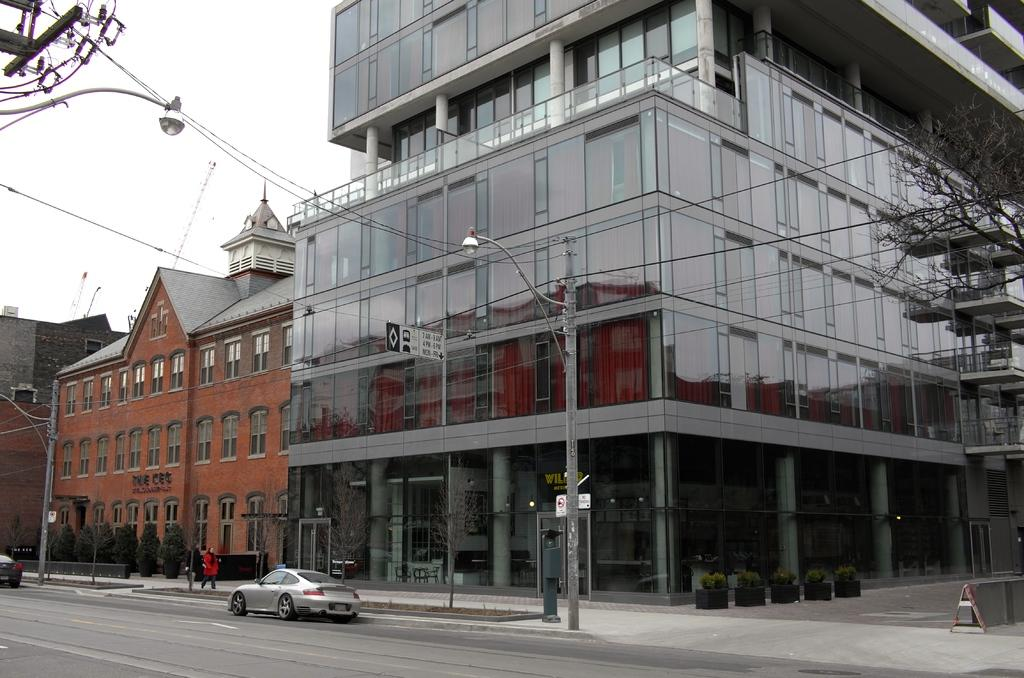What type of structures can be seen in the image? There are buildings in the image. What other elements are present in the image besides buildings? There are plants, poles, lights, wires, persons, boards, vehicles on the road, and a road divider in the image. Can you describe the road in the image? The road has a divider and vehicles on it. What might be the purpose of the boards in the image? The boards could be used for advertising or displaying information. What type of window can be seen in the image? There is no window present in the image. What action are the persons in the image performing? The provided facts do not specify any actions being performed by the persons in the image. 